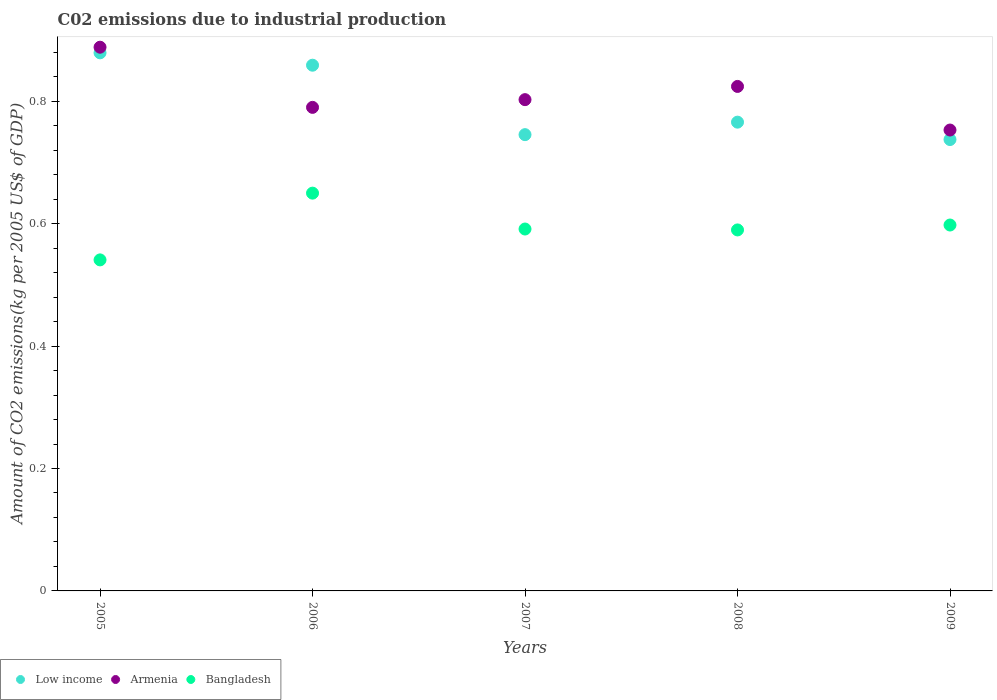How many different coloured dotlines are there?
Ensure brevity in your answer.  3. What is the amount of CO2 emitted due to industrial production in Bangladesh in 2005?
Ensure brevity in your answer.  0.54. Across all years, what is the maximum amount of CO2 emitted due to industrial production in Armenia?
Offer a terse response. 0.89. Across all years, what is the minimum amount of CO2 emitted due to industrial production in Bangladesh?
Provide a short and direct response. 0.54. In which year was the amount of CO2 emitted due to industrial production in Armenia maximum?
Your answer should be very brief. 2005. What is the total amount of CO2 emitted due to industrial production in Low income in the graph?
Keep it short and to the point. 3.99. What is the difference between the amount of CO2 emitted due to industrial production in Bangladesh in 2005 and that in 2008?
Provide a succinct answer. -0.05. What is the difference between the amount of CO2 emitted due to industrial production in Bangladesh in 2008 and the amount of CO2 emitted due to industrial production in Armenia in 2009?
Ensure brevity in your answer.  -0.16. What is the average amount of CO2 emitted due to industrial production in Bangladesh per year?
Ensure brevity in your answer.  0.59. In the year 2005, what is the difference between the amount of CO2 emitted due to industrial production in Bangladesh and amount of CO2 emitted due to industrial production in Armenia?
Ensure brevity in your answer.  -0.35. In how many years, is the amount of CO2 emitted due to industrial production in Armenia greater than 0.56 kg?
Offer a very short reply. 5. What is the ratio of the amount of CO2 emitted due to industrial production in Armenia in 2006 to that in 2009?
Offer a terse response. 1.05. Is the difference between the amount of CO2 emitted due to industrial production in Bangladesh in 2007 and 2009 greater than the difference between the amount of CO2 emitted due to industrial production in Armenia in 2007 and 2009?
Your answer should be compact. No. What is the difference between the highest and the second highest amount of CO2 emitted due to industrial production in Low income?
Your answer should be very brief. 0.02. What is the difference between the highest and the lowest amount of CO2 emitted due to industrial production in Armenia?
Keep it short and to the point. 0.14. Does the amount of CO2 emitted due to industrial production in Armenia monotonically increase over the years?
Offer a very short reply. No. Is the amount of CO2 emitted due to industrial production in Bangladesh strictly less than the amount of CO2 emitted due to industrial production in Armenia over the years?
Your answer should be very brief. Yes. How many dotlines are there?
Ensure brevity in your answer.  3. How many years are there in the graph?
Provide a succinct answer. 5. Does the graph contain grids?
Ensure brevity in your answer.  No. Where does the legend appear in the graph?
Make the answer very short. Bottom left. How many legend labels are there?
Offer a very short reply. 3. What is the title of the graph?
Offer a terse response. C02 emissions due to industrial production. What is the label or title of the X-axis?
Your response must be concise. Years. What is the label or title of the Y-axis?
Offer a very short reply. Amount of CO2 emissions(kg per 2005 US$ of GDP). What is the Amount of CO2 emissions(kg per 2005 US$ of GDP) in Low income in 2005?
Offer a very short reply. 0.88. What is the Amount of CO2 emissions(kg per 2005 US$ of GDP) of Armenia in 2005?
Provide a succinct answer. 0.89. What is the Amount of CO2 emissions(kg per 2005 US$ of GDP) of Bangladesh in 2005?
Your answer should be compact. 0.54. What is the Amount of CO2 emissions(kg per 2005 US$ of GDP) of Low income in 2006?
Give a very brief answer. 0.86. What is the Amount of CO2 emissions(kg per 2005 US$ of GDP) of Armenia in 2006?
Provide a short and direct response. 0.79. What is the Amount of CO2 emissions(kg per 2005 US$ of GDP) in Bangladesh in 2006?
Make the answer very short. 0.65. What is the Amount of CO2 emissions(kg per 2005 US$ of GDP) of Low income in 2007?
Ensure brevity in your answer.  0.75. What is the Amount of CO2 emissions(kg per 2005 US$ of GDP) in Armenia in 2007?
Keep it short and to the point. 0.8. What is the Amount of CO2 emissions(kg per 2005 US$ of GDP) of Bangladesh in 2007?
Your answer should be very brief. 0.59. What is the Amount of CO2 emissions(kg per 2005 US$ of GDP) in Low income in 2008?
Your response must be concise. 0.77. What is the Amount of CO2 emissions(kg per 2005 US$ of GDP) in Armenia in 2008?
Your answer should be compact. 0.82. What is the Amount of CO2 emissions(kg per 2005 US$ of GDP) in Bangladesh in 2008?
Offer a very short reply. 0.59. What is the Amount of CO2 emissions(kg per 2005 US$ of GDP) of Low income in 2009?
Your response must be concise. 0.74. What is the Amount of CO2 emissions(kg per 2005 US$ of GDP) in Armenia in 2009?
Offer a terse response. 0.75. What is the Amount of CO2 emissions(kg per 2005 US$ of GDP) in Bangladesh in 2009?
Make the answer very short. 0.6. Across all years, what is the maximum Amount of CO2 emissions(kg per 2005 US$ of GDP) in Low income?
Your response must be concise. 0.88. Across all years, what is the maximum Amount of CO2 emissions(kg per 2005 US$ of GDP) in Armenia?
Your answer should be very brief. 0.89. Across all years, what is the maximum Amount of CO2 emissions(kg per 2005 US$ of GDP) in Bangladesh?
Offer a very short reply. 0.65. Across all years, what is the minimum Amount of CO2 emissions(kg per 2005 US$ of GDP) in Low income?
Your answer should be compact. 0.74. Across all years, what is the minimum Amount of CO2 emissions(kg per 2005 US$ of GDP) in Armenia?
Your response must be concise. 0.75. Across all years, what is the minimum Amount of CO2 emissions(kg per 2005 US$ of GDP) in Bangladesh?
Offer a very short reply. 0.54. What is the total Amount of CO2 emissions(kg per 2005 US$ of GDP) of Low income in the graph?
Offer a terse response. 3.99. What is the total Amount of CO2 emissions(kg per 2005 US$ of GDP) of Armenia in the graph?
Provide a succinct answer. 4.06. What is the total Amount of CO2 emissions(kg per 2005 US$ of GDP) in Bangladesh in the graph?
Offer a very short reply. 2.97. What is the difference between the Amount of CO2 emissions(kg per 2005 US$ of GDP) of Low income in 2005 and that in 2006?
Provide a short and direct response. 0.02. What is the difference between the Amount of CO2 emissions(kg per 2005 US$ of GDP) of Armenia in 2005 and that in 2006?
Make the answer very short. 0.1. What is the difference between the Amount of CO2 emissions(kg per 2005 US$ of GDP) in Bangladesh in 2005 and that in 2006?
Offer a very short reply. -0.11. What is the difference between the Amount of CO2 emissions(kg per 2005 US$ of GDP) of Low income in 2005 and that in 2007?
Offer a very short reply. 0.13. What is the difference between the Amount of CO2 emissions(kg per 2005 US$ of GDP) in Armenia in 2005 and that in 2007?
Keep it short and to the point. 0.09. What is the difference between the Amount of CO2 emissions(kg per 2005 US$ of GDP) of Bangladesh in 2005 and that in 2007?
Offer a terse response. -0.05. What is the difference between the Amount of CO2 emissions(kg per 2005 US$ of GDP) in Low income in 2005 and that in 2008?
Ensure brevity in your answer.  0.11. What is the difference between the Amount of CO2 emissions(kg per 2005 US$ of GDP) in Armenia in 2005 and that in 2008?
Your answer should be very brief. 0.06. What is the difference between the Amount of CO2 emissions(kg per 2005 US$ of GDP) in Bangladesh in 2005 and that in 2008?
Your answer should be very brief. -0.05. What is the difference between the Amount of CO2 emissions(kg per 2005 US$ of GDP) of Low income in 2005 and that in 2009?
Ensure brevity in your answer.  0.14. What is the difference between the Amount of CO2 emissions(kg per 2005 US$ of GDP) in Armenia in 2005 and that in 2009?
Give a very brief answer. 0.14. What is the difference between the Amount of CO2 emissions(kg per 2005 US$ of GDP) in Bangladesh in 2005 and that in 2009?
Provide a short and direct response. -0.06. What is the difference between the Amount of CO2 emissions(kg per 2005 US$ of GDP) in Low income in 2006 and that in 2007?
Keep it short and to the point. 0.11. What is the difference between the Amount of CO2 emissions(kg per 2005 US$ of GDP) in Armenia in 2006 and that in 2007?
Provide a short and direct response. -0.01. What is the difference between the Amount of CO2 emissions(kg per 2005 US$ of GDP) of Bangladesh in 2006 and that in 2007?
Your answer should be compact. 0.06. What is the difference between the Amount of CO2 emissions(kg per 2005 US$ of GDP) in Low income in 2006 and that in 2008?
Ensure brevity in your answer.  0.09. What is the difference between the Amount of CO2 emissions(kg per 2005 US$ of GDP) in Armenia in 2006 and that in 2008?
Your answer should be very brief. -0.03. What is the difference between the Amount of CO2 emissions(kg per 2005 US$ of GDP) of Bangladesh in 2006 and that in 2008?
Provide a short and direct response. 0.06. What is the difference between the Amount of CO2 emissions(kg per 2005 US$ of GDP) of Low income in 2006 and that in 2009?
Your answer should be very brief. 0.12. What is the difference between the Amount of CO2 emissions(kg per 2005 US$ of GDP) in Armenia in 2006 and that in 2009?
Your answer should be compact. 0.04. What is the difference between the Amount of CO2 emissions(kg per 2005 US$ of GDP) of Bangladesh in 2006 and that in 2009?
Ensure brevity in your answer.  0.05. What is the difference between the Amount of CO2 emissions(kg per 2005 US$ of GDP) in Low income in 2007 and that in 2008?
Your response must be concise. -0.02. What is the difference between the Amount of CO2 emissions(kg per 2005 US$ of GDP) in Armenia in 2007 and that in 2008?
Provide a succinct answer. -0.02. What is the difference between the Amount of CO2 emissions(kg per 2005 US$ of GDP) in Bangladesh in 2007 and that in 2008?
Give a very brief answer. 0. What is the difference between the Amount of CO2 emissions(kg per 2005 US$ of GDP) of Low income in 2007 and that in 2009?
Make the answer very short. 0.01. What is the difference between the Amount of CO2 emissions(kg per 2005 US$ of GDP) in Armenia in 2007 and that in 2009?
Your response must be concise. 0.05. What is the difference between the Amount of CO2 emissions(kg per 2005 US$ of GDP) of Bangladesh in 2007 and that in 2009?
Your answer should be compact. -0.01. What is the difference between the Amount of CO2 emissions(kg per 2005 US$ of GDP) in Low income in 2008 and that in 2009?
Provide a succinct answer. 0.03. What is the difference between the Amount of CO2 emissions(kg per 2005 US$ of GDP) of Armenia in 2008 and that in 2009?
Your response must be concise. 0.07. What is the difference between the Amount of CO2 emissions(kg per 2005 US$ of GDP) of Bangladesh in 2008 and that in 2009?
Ensure brevity in your answer.  -0.01. What is the difference between the Amount of CO2 emissions(kg per 2005 US$ of GDP) of Low income in 2005 and the Amount of CO2 emissions(kg per 2005 US$ of GDP) of Armenia in 2006?
Make the answer very short. 0.09. What is the difference between the Amount of CO2 emissions(kg per 2005 US$ of GDP) in Low income in 2005 and the Amount of CO2 emissions(kg per 2005 US$ of GDP) in Bangladesh in 2006?
Offer a terse response. 0.23. What is the difference between the Amount of CO2 emissions(kg per 2005 US$ of GDP) of Armenia in 2005 and the Amount of CO2 emissions(kg per 2005 US$ of GDP) of Bangladesh in 2006?
Offer a very short reply. 0.24. What is the difference between the Amount of CO2 emissions(kg per 2005 US$ of GDP) of Low income in 2005 and the Amount of CO2 emissions(kg per 2005 US$ of GDP) of Armenia in 2007?
Offer a very short reply. 0.08. What is the difference between the Amount of CO2 emissions(kg per 2005 US$ of GDP) in Low income in 2005 and the Amount of CO2 emissions(kg per 2005 US$ of GDP) in Bangladesh in 2007?
Provide a short and direct response. 0.29. What is the difference between the Amount of CO2 emissions(kg per 2005 US$ of GDP) in Armenia in 2005 and the Amount of CO2 emissions(kg per 2005 US$ of GDP) in Bangladesh in 2007?
Ensure brevity in your answer.  0.3. What is the difference between the Amount of CO2 emissions(kg per 2005 US$ of GDP) of Low income in 2005 and the Amount of CO2 emissions(kg per 2005 US$ of GDP) of Armenia in 2008?
Keep it short and to the point. 0.05. What is the difference between the Amount of CO2 emissions(kg per 2005 US$ of GDP) in Low income in 2005 and the Amount of CO2 emissions(kg per 2005 US$ of GDP) in Bangladesh in 2008?
Ensure brevity in your answer.  0.29. What is the difference between the Amount of CO2 emissions(kg per 2005 US$ of GDP) in Armenia in 2005 and the Amount of CO2 emissions(kg per 2005 US$ of GDP) in Bangladesh in 2008?
Keep it short and to the point. 0.3. What is the difference between the Amount of CO2 emissions(kg per 2005 US$ of GDP) in Low income in 2005 and the Amount of CO2 emissions(kg per 2005 US$ of GDP) in Armenia in 2009?
Your answer should be very brief. 0.13. What is the difference between the Amount of CO2 emissions(kg per 2005 US$ of GDP) in Low income in 2005 and the Amount of CO2 emissions(kg per 2005 US$ of GDP) in Bangladesh in 2009?
Your answer should be compact. 0.28. What is the difference between the Amount of CO2 emissions(kg per 2005 US$ of GDP) in Armenia in 2005 and the Amount of CO2 emissions(kg per 2005 US$ of GDP) in Bangladesh in 2009?
Your response must be concise. 0.29. What is the difference between the Amount of CO2 emissions(kg per 2005 US$ of GDP) in Low income in 2006 and the Amount of CO2 emissions(kg per 2005 US$ of GDP) in Armenia in 2007?
Ensure brevity in your answer.  0.06. What is the difference between the Amount of CO2 emissions(kg per 2005 US$ of GDP) in Low income in 2006 and the Amount of CO2 emissions(kg per 2005 US$ of GDP) in Bangladesh in 2007?
Provide a short and direct response. 0.27. What is the difference between the Amount of CO2 emissions(kg per 2005 US$ of GDP) in Armenia in 2006 and the Amount of CO2 emissions(kg per 2005 US$ of GDP) in Bangladesh in 2007?
Give a very brief answer. 0.2. What is the difference between the Amount of CO2 emissions(kg per 2005 US$ of GDP) of Low income in 2006 and the Amount of CO2 emissions(kg per 2005 US$ of GDP) of Armenia in 2008?
Give a very brief answer. 0.03. What is the difference between the Amount of CO2 emissions(kg per 2005 US$ of GDP) of Low income in 2006 and the Amount of CO2 emissions(kg per 2005 US$ of GDP) of Bangladesh in 2008?
Give a very brief answer. 0.27. What is the difference between the Amount of CO2 emissions(kg per 2005 US$ of GDP) of Armenia in 2006 and the Amount of CO2 emissions(kg per 2005 US$ of GDP) of Bangladesh in 2008?
Keep it short and to the point. 0.2. What is the difference between the Amount of CO2 emissions(kg per 2005 US$ of GDP) in Low income in 2006 and the Amount of CO2 emissions(kg per 2005 US$ of GDP) in Armenia in 2009?
Give a very brief answer. 0.11. What is the difference between the Amount of CO2 emissions(kg per 2005 US$ of GDP) in Low income in 2006 and the Amount of CO2 emissions(kg per 2005 US$ of GDP) in Bangladesh in 2009?
Your answer should be compact. 0.26. What is the difference between the Amount of CO2 emissions(kg per 2005 US$ of GDP) in Armenia in 2006 and the Amount of CO2 emissions(kg per 2005 US$ of GDP) in Bangladesh in 2009?
Your answer should be very brief. 0.19. What is the difference between the Amount of CO2 emissions(kg per 2005 US$ of GDP) of Low income in 2007 and the Amount of CO2 emissions(kg per 2005 US$ of GDP) of Armenia in 2008?
Ensure brevity in your answer.  -0.08. What is the difference between the Amount of CO2 emissions(kg per 2005 US$ of GDP) of Low income in 2007 and the Amount of CO2 emissions(kg per 2005 US$ of GDP) of Bangladesh in 2008?
Your answer should be very brief. 0.16. What is the difference between the Amount of CO2 emissions(kg per 2005 US$ of GDP) in Armenia in 2007 and the Amount of CO2 emissions(kg per 2005 US$ of GDP) in Bangladesh in 2008?
Make the answer very short. 0.21. What is the difference between the Amount of CO2 emissions(kg per 2005 US$ of GDP) in Low income in 2007 and the Amount of CO2 emissions(kg per 2005 US$ of GDP) in Armenia in 2009?
Your answer should be compact. -0.01. What is the difference between the Amount of CO2 emissions(kg per 2005 US$ of GDP) of Low income in 2007 and the Amount of CO2 emissions(kg per 2005 US$ of GDP) of Bangladesh in 2009?
Make the answer very short. 0.15. What is the difference between the Amount of CO2 emissions(kg per 2005 US$ of GDP) in Armenia in 2007 and the Amount of CO2 emissions(kg per 2005 US$ of GDP) in Bangladesh in 2009?
Ensure brevity in your answer.  0.2. What is the difference between the Amount of CO2 emissions(kg per 2005 US$ of GDP) of Low income in 2008 and the Amount of CO2 emissions(kg per 2005 US$ of GDP) of Armenia in 2009?
Give a very brief answer. 0.01. What is the difference between the Amount of CO2 emissions(kg per 2005 US$ of GDP) of Low income in 2008 and the Amount of CO2 emissions(kg per 2005 US$ of GDP) of Bangladesh in 2009?
Your answer should be very brief. 0.17. What is the difference between the Amount of CO2 emissions(kg per 2005 US$ of GDP) in Armenia in 2008 and the Amount of CO2 emissions(kg per 2005 US$ of GDP) in Bangladesh in 2009?
Provide a succinct answer. 0.23. What is the average Amount of CO2 emissions(kg per 2005 US$ of GDP) of Low income per year?
Make the answer very short. 0.8. What is the average Amount of CO2 emissions(kg per 2005 US$ of GDP) in Armenia per year?
Your answer should be very brief. 0.81. What is the average Amount of CO2 emissions(kg per 2005 US$ of GDP) of Bangladesh per year?
Ensure brevity in your answer.  0.59. In the year 2005, what is the difference between the Amount of CO2 emissions(kg per 2005 US$ of GDP) in Low income and Amount of CO2 emissions(kg per 2005 US$ of GDP) in Armenia?
Make the answer very short. -0.01. In the year 2005, what is the difference between the Amount of CO2 emissions(kg per 2005 US$ of GDP) in Low income and Amount of CO2 emissions(kg per 2005 US$ of GDP) in Bangladesh?
Offer a very short reply. 0.34. In the year 2005, what is the difference between the Amount of CO2 emissions(kg per 2005 US$ of GDP) in Armenia and Amount of CO2 emissions(kg per 2005 US$ of GDP) in Bangladesh?
Offer a terse response. 0.35. In the year 2006, what is the difference between the Amount of CO2 emissions(kg per 2005 US$ of GDP) of Low income and Amount of CO2 emissions(kg per 2005 US$ of GDP) of Armenia?
Offer a very short reply. 0.07. In the year 2006, what is the difference between the Amount of CO2 emissions(kg per 2005 US$ of GDP) in Low income and Amount of CO2 emissions(kg per 2005 US$ of GDP) in Bangladesh?
Your answer should be very brief. 0.21. In the year 2006, what is the difference between the Amount of CO2 emissions(kg per 2005 US$ of GDP) of Armenia and Amount of CO2 emissions(kg per 2005 US$ of GDP) of Bangladesh?
Your answer should be compact. 0.14. In the year 2007, what is the difference between the Amount of CO2 emissions(kg per 2005 US$ of GDP) in Low income and Amount of CO2 emissions(kg per 2005 US$ of GDP) in Armenia?
Your answer should be compact. -0.06. In the year 2007, what is the difference between the Amount of CO2 emissions(kg per 2005 US$ of GDP) of Low income and Amount of CO2 emissions(kg per 2005 US$ of GDP) of Bangladesh?
Provide a succinct answer. 0.15. In the year 2007, what is the difference between the Amount of CO2 emissions(kg per 2005 US$ of GDP) in Armenia and Amount of CO2 emissions(kg per 2005 US$ of GDP) in Bangladesh?
Your answer should be very brief. 0.21. In the year 2008, what is the difference between the Amount of CO2 emissions(kg per 2005 US$ of GDP) in Low income and Amount of CO2 emissions(kg per 2005 US$ of GDP) in Armenia?
Your answer should be very brief. -0.06. In the year 2008, what is the difference between the Amount of CO2 emissions(kg per 2005 US$ of GDP) in Low income and Amount of CO2 emissions(kg per 2005 US$ of GDP) in Bangladesh?
Provide a short and direct response. 0.18. In the year 2008, what is the difference between the Amount of CO2 emissions(kg per 2005 US$ of GDP) in Armenia and Amount of CO2 emissions(kg per 2005 US$ of GDP) in Bangladesh?
Provide a short and direct response. 0.23. In the year 2009, what is the difference between the Amount of CO2 emissions(kg per 2005 US$ of GDP) in Low income and Amount of CO2 emissions(kg per 2005 US$ of GDP) in Armenia?
Your answer should be compact. -0.02. In the year 2009, what is the difference between the Amount of CO2 emissions(kg per 2005 US$ of GDP) of Low income and Amount of CO2 emissions(kg per 2005 US$ of GDP) of Bangladesh?
Your answer should be very brief. 0.14. In the year 2009, what is the difference between the Amount of CO2 emissions(kg per 2005 US$ of GDP) in Armenia and Amount of CO2 emissions(kg per 2005 US$ of GDP) in Bangladesh?
Provide a succinct answer. 0.16. What is the ratio of the Amount of CO2 emissions(kg per 2005 US$ of GDP) in Low income in 2005 to that in 2006?
Make the answer very short. 1.02. What is the ratio of the Amount of CO2 emissions(kg per 2005 US$ of GDP) of Armenia in 2005 to that in 2006?
Your answer should be compact. 1.12. What is the ratio of the Amount of CO2 emissions(kg per 2005 US$ of GDP) in Bangladesh in 2005 to that in 2006?
Your answer should be compact. 0.83. What is the ratio of the Amount of CO2 emissions(kg per 2005 US$ of GDP) of Low income in 2005 to that in 2007?
Make the answer very short. 1.18. What is the ratio of the Amount of CO2 emissions(kg per 2005 US$ of GDP) in Armenia in 2005 to that in 2007?
Offer a very short reply. 1.11. What is the ratio of the Amount of CO2 emissions(kg per 2005 US$ of GDP) of Bangladesh in 2005 to that in 2007?
Ensure brevity in your answer.  0.91. What is the ratio of the Amount of CO2 emissions(kg per 2005 US$ of GDP) of Low income in 2005 to that in 2008?
Provide a succinct answer. 1.15. What is the ratio of the Amount of CO2 emissions(kg per 2005 US$ of GDP) of Armenia in 2005 to that in 2008?
Provide a succinct answer. 1.08. What is the ratio of the Amount of CO2 emissions(kg per 2005 US$ of GDP) of Bangladesh in 2005 to that in 2008?
Offer a very short reply. 0.92. What is the ratio of the Amount of CO2 emissions(kg per 2005 US$ of GDP) in Low income in 2005 to that in 2009?
Offer a terse response. 1.19. What is the ratio of the Amount of CO2 emissions(kg per 2005 US$ of GDP) in Armenia in 2005 to that in 2009?
Your response must be concise. 1.18. What is the ratio of the Amount of CO2 emissions(kg per 2005 US$ of GDP) of Bangladesh in 2005 to that in 2009?
Make the answer very short. 0.9. What is the ratio of the Amount of CO2 emissions(kg per 2005 US$ of GDP) in Low income in 2006 to that in 2007?
Offer a terse response. 1.15. What is the ratio of the Amount of CO2 emissions(kg per 2005 US$ of GDP) of Armenia in 2006 to that in 2007?
Provide a short and direct response. 0.98. What is the ratio of the Amount of CO2 emissions(kg per 2005 US$ of GDP) in Bangladesh in 2006 to that in 2007?
Offer a terse response. 1.1. What is the ratio of the Amount of CO2 emissions(kg per 2005 US$ of GDP) of Low income in 2006 to that in 2008?
Ensure brevity in your answer.  1.12. What is the ratio of the Amount of CO2 emissions(kg per 2005 US$ of GDP) in Armenia in 2006 to that in 2008?
Provide a succinct answer. 0.96. What is the ratio of the Amount of CO2 emissions(kg per 2005 US$ of GDP) of Bangladesh in 2006 to that in 2008?
Provide a succinct answer. 1.1. What is the ratio of the Amount of CO2 emissions(kg per 2005 US$ of GDP) of Low income in 2006 to that in 2009?
Give a very brief answer. 1.16. What is the ratio of the Amount of CO2 emissions(kg per 2005 US$ of GDP) of Armenia in 2006 to that in 2009?
Your response must be concise. 1.05. What is the ratio of the Amount of CO2 emissions(kg per 2005 US$ of GDP) of Bangladesh in 2006 to that in 2009?
Provide a short and direct response. 1.09. What is the ratio of the Amount of CO2 emissions(kg per 2005 US$ of GDP) of Low income in 2007 to that in 2008?
Your answer should be compact. 0.97. What is the ratio of the Amount of CO2 emissions(kg per 2005 US$ of GDP) in Armenia in 2007 to that in 2008?
Offer a very short reply. 0.97. What is the ratio of the Amount of CO2 emissions(kg per 2005 US$ of GDP) in Low income in 2007 to that in 2009?
Make the answer very short. 1.01. What is the ratio of the Amount of CO2 emissions(kg per 2005 US$ of GDP) of Armenia in 2007 to that in 2009?
Provide a short and direct response. 1.07. What is the ratio of the Amount of CO2 emissions(kg per 2005 US$ of GDP) in Bangladesh in 2007 to that in 2009?
Provide a short and direct response. 0.99. What is the ratio of the Amount of CO2 emissions(kg per 2005 US$ of GDP) of Low income in 2008 to that in 2009?
Make the answer very short. 1.04. What is the ratio of the Amount of CO2 emissions(kg per 2005 US$ of GDP) in Armenia in 2008 to that in 2009?
Your answer should be very brief. 1.09. What is the ratio of the Amount of CO2 emissions(kg per 2005 US$ of GDP) in Bangladesh in 2008 to that in 2009?
Your response must be concise. 0.99. What is the difference between the highest and the second highest Amount of CO2 emissions(kg per 2005 US$ of GDP) in Low income?
Offer a very short reply. 0.02. What is the difference between the highest and the second highest Amount of CO2 emissions(kg per 2005 US$ of GDP) in Armenia?
Provide a short and direct response. 0.06. What is the difference between the highest and the second highest Amount of CO2 emissions(kg per 2005 US$ of GDP) of Bangladesh?
Provide a short and direct response. 0.05. What is the difference between the highest and the lowest Amount of CO2 emissions(kg per 2005 US$ of GDP) in Low income?
Your answer should be compact. 0.14. What is the difference between the highest and the lowest Amount of CO2 emissions(kg per 2005 US$ of GDP) of Armenia?
Offer a terse response. 0.14. What is the difference between the highest and the lowest Amount of CO2 emissions(kg per 2005 US$ of GDP) in Bangladesh?
Your answer should be very brief. 0.11. 